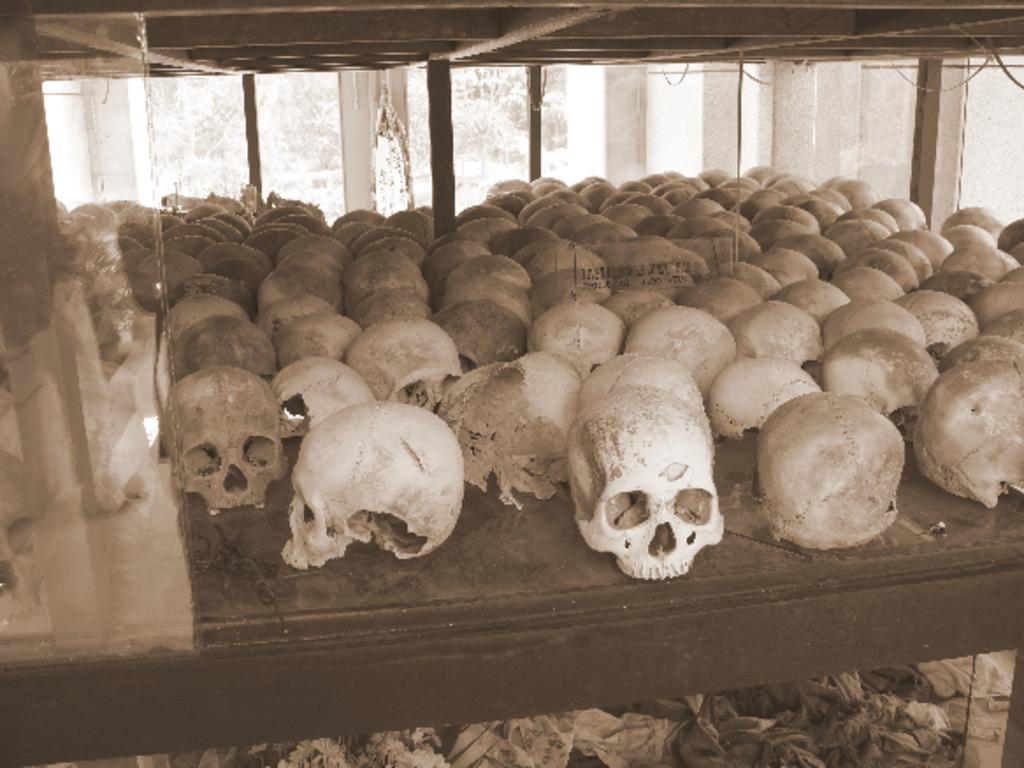What objects are on the table in the image? There are skulls on a table in the image. What type of structure is visible in the image? There is a glass window visible in the image. What can be seen through the glass window? Trees are visible through the glass window. Where might this image have been taken? The image might have been taken in a museum, given the presence of skulls. How many hens can be seen in the image? There are no hens present in the image. What part of the brain is visible in the image? There is no brain visible in the image; it features skulls on a table. 